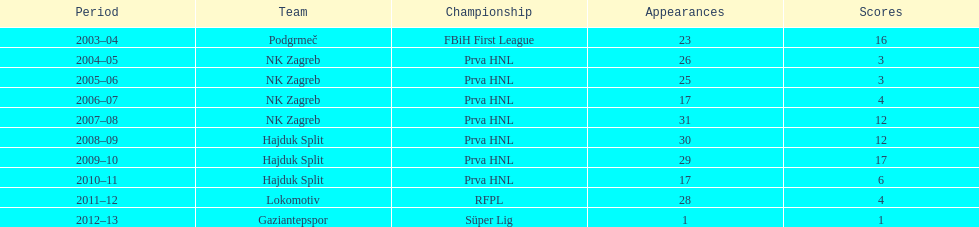What were the names of each club where more than 15 goals were scored in a single season? Podgrmeč, Hajduk Split. 